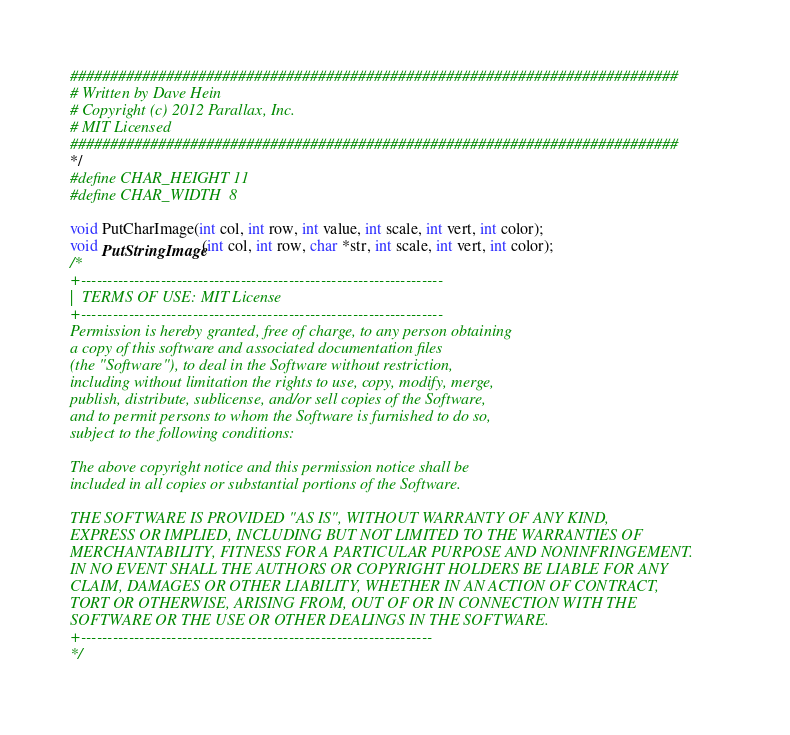Convert code to text. <code><loc_0><loc_0><loc_500><loc_500><_C_>############################################################################
# Written by Dave Hein
# Copyright (c) 2012 Parallax, Inc.
# MIT Licensed
############################################################################
*/
#define CHAR_HEIGHT 11
#define CHAR_WIDTH  8

void PutCharImage(int col, int row, int value, int scale, int vert, int color);
void PutStringImage(int col, int row, char *str, int scale, int vert, int color);
/*
+--------------------------------------------------------------------
|  TERMS OF USE: MIT License
+--------------------------------------------------------------------
Permission is hereby granted, free of charge, to any person obtaining
a copy of this software and associated documentation files
(the "Software"), to deal in the Software without restriction,
including without limitation the rights to use, copy, modify, merge,
publish, distribute, sublicense, and/or sell copies of the Software,
and to permit persons to whom the Software is furnished to do so,
subject to the following conditions:

The above copyright notice and this permission notice shall be
included in all copies or substantial portions of the Software.

THE SOFTWARE IS PROVIDED "AS IS", WITHOUT WARRANTY OF ANY KIND,
EXPRESS OR IMPLIED, INCLUDING BUT NOT LIMITED TO THE WARRANTIES OF
MERCHANTABILITY, FITNESS FOR A PARTICULAR PURPOSE AND NONINFRINGEMENT.
IN NO EVENT SHALL THE AUTHORS OR COPYRIGHT HOLDERS BE LIABLE FOR ANY
CLAIM, DAMAGES OR OTHER LIABILITY, WHETHER IN AN ACTION OF CONTRACT,
TORT OR OTHERWISE, ARISING FROM, OUT OF OR IN CONNECTION WITH THE
SOFTWARE OR THE USE OR OTHER DEALINGS IN THE SOFTWARE.
+------------------------------------------------------------------
*/

</code> 